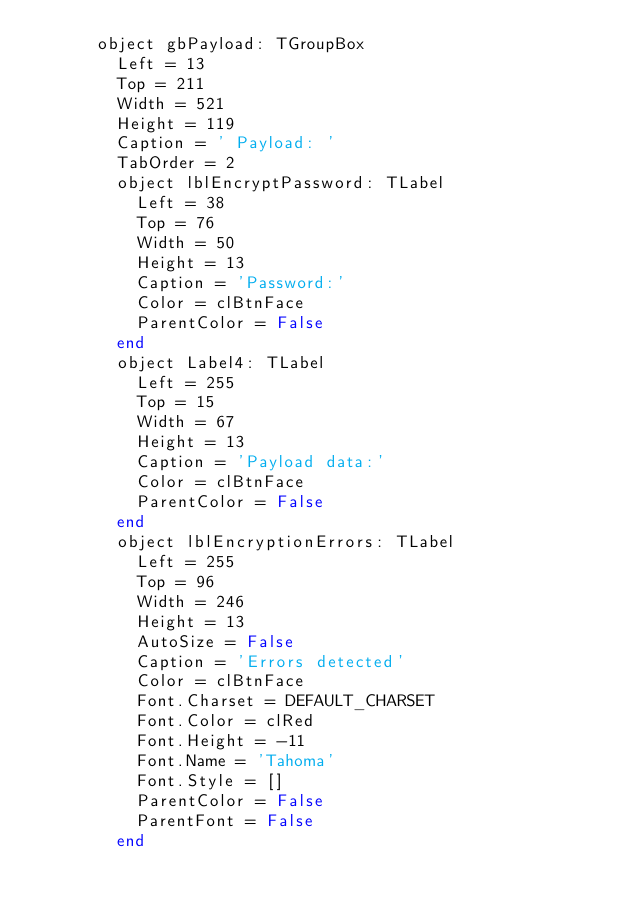Convert code to text. <code><loc_0><loc_0><loc_500><loc_500><_Pascal_>      object gbPayload: TGroupBox
        Left = 13
        Top = 211
        Width = 521
        Height = 119
        Caption = ' Payload: '
        TabOrder = 2
        object lblEncryptPassword: TLabel
          Left = 38
          Top = 76
          Width = 50
          Height = 13
          Caption = 'Password:'
          Color = clBtnFace
          ParentColor = False
        end
        object Label4: TLabel
          Left = 255
          Top = 15
          Width = 67
          Height = 13
          Caption = 'Payload data:'
          Color = clBtnFace
          ParentColor = False
        end
        object lblEncryptionErrors: TLabel
          Left = 255
          Top = 96
          Width = 246
          Height = 13
          AutoSize = False
          Caption = 'Errors detected'
          Color = clBtnFace
          Font.Charset = DEFAULT_CHARSET
          Font.Color = clRed
          Font.Height = -11
          Font.Name = 'Tahoma'
          Font.Style = []
          ParentColor = False
          ParentFont = False
        end</code> 